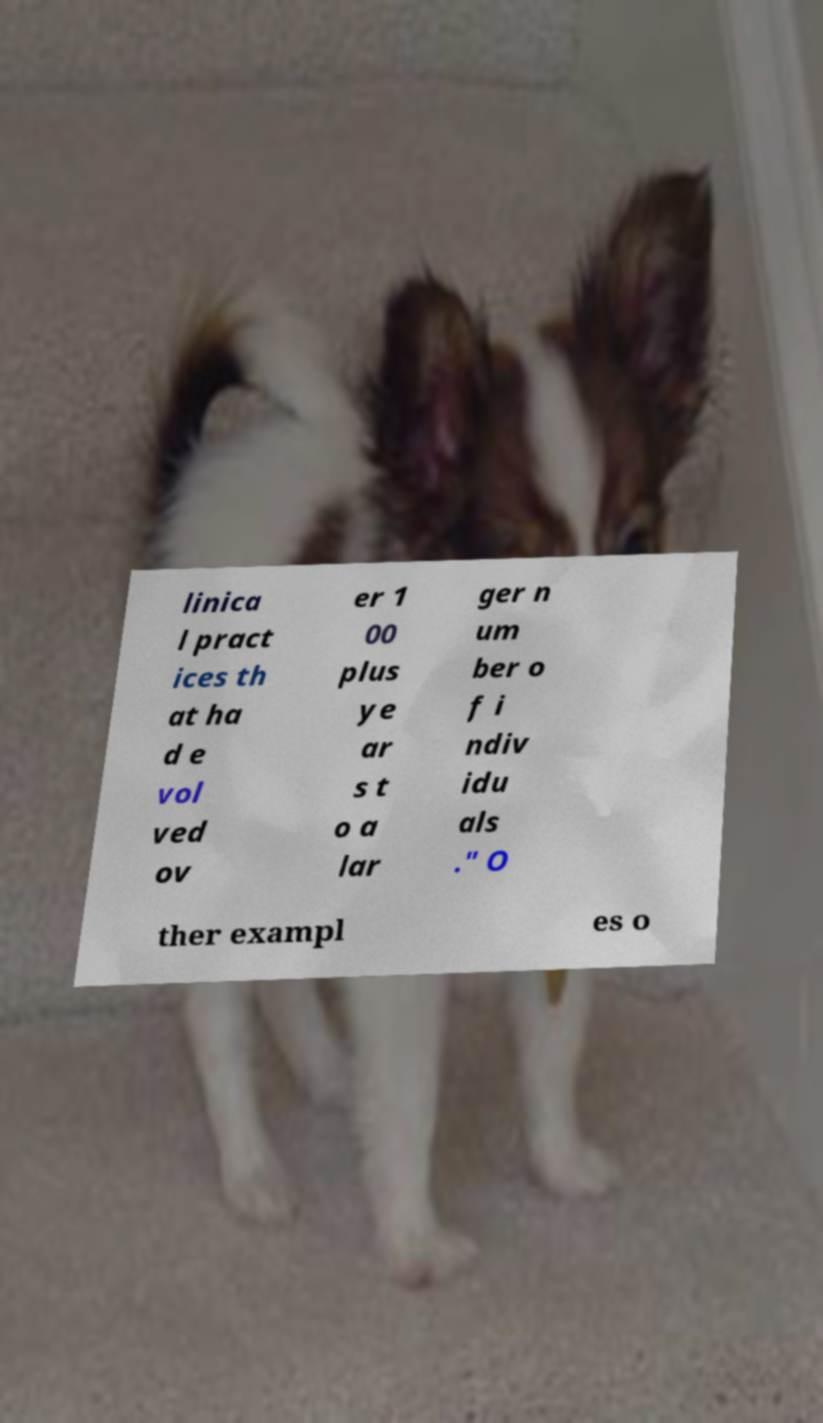Can you read and provide the text displayed in the image?This photo seems to have some interesting text. Can you extract and type it out for me? linica l pract ices th at ha d e vol ved ov er 1 00 plus ye ar s t o a lar ger n um ber o f i ndiv idu als ." O ther exampl es o 